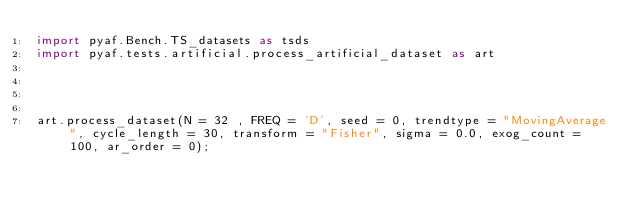Convert code to text. <code><loc_0><loc_0><loc_500><loc_500><_Python_>import pyaf.Bench.TS_datasets as tsds
import pyaf.tests.artificial.process_artificial_dataset as art




art.process_dataset(N = 32 , FREQ = 'D', seed = 0, trendtype = "MovingAverage", cycle_length = 30, transform = "Fisher", sigma = 0.0, exog_count = 100, ar_order = 0);</code> 